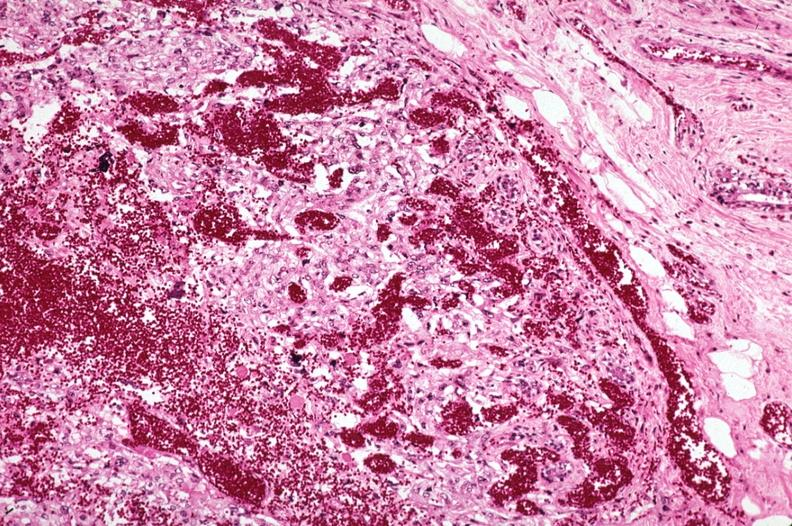does this image show metastatic choriocarcinoma with extensive vascularization?
Answer the question using a single word or phrase. Yes 